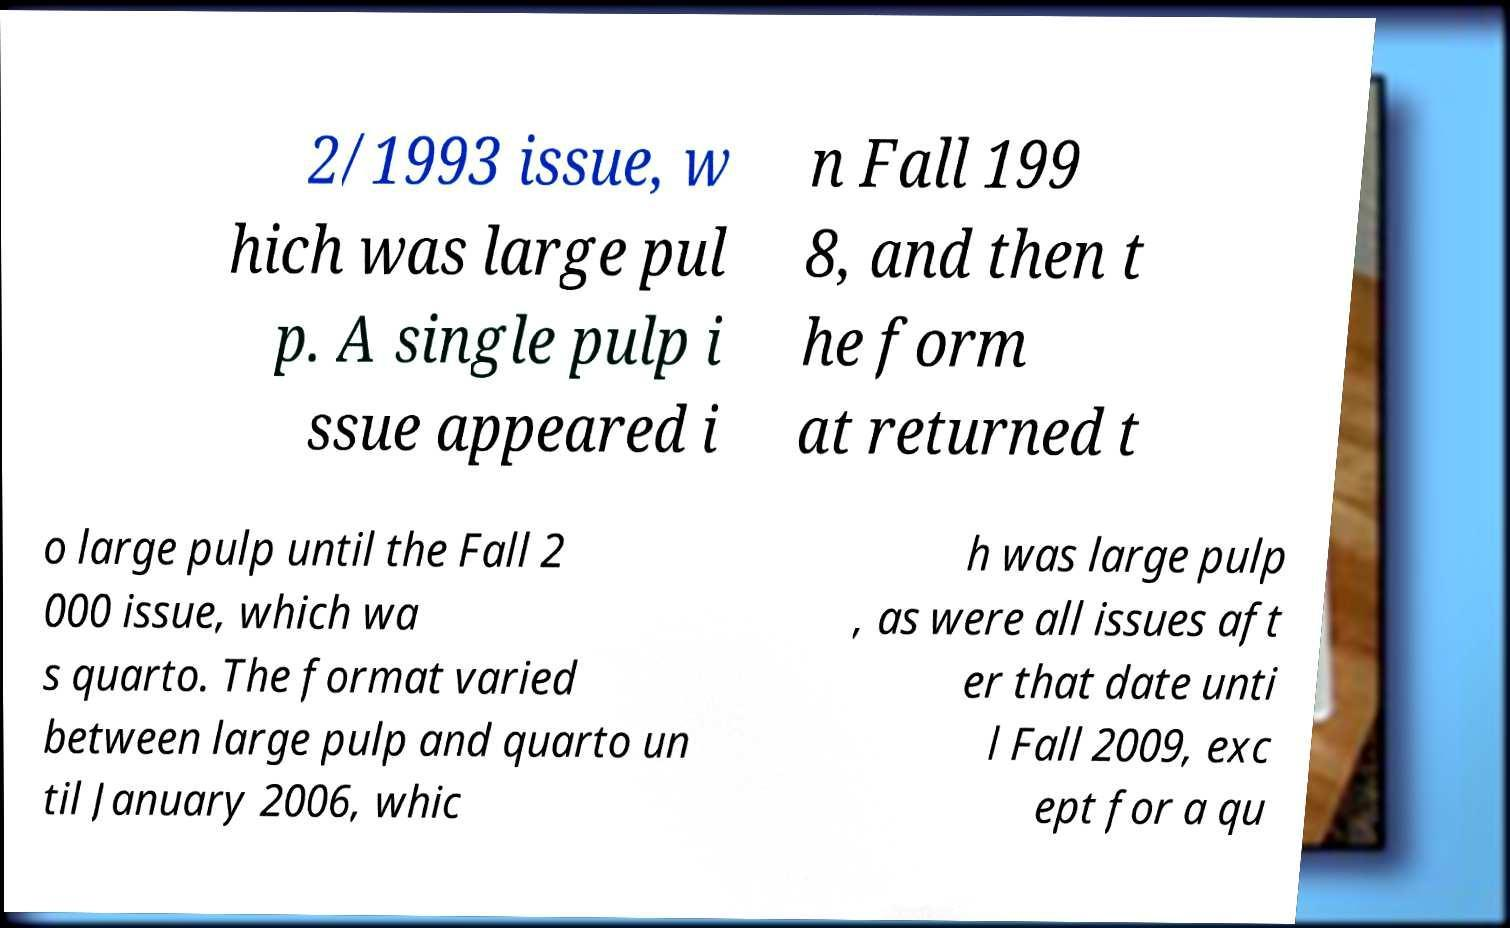Can you read and provide the text displayed in the image?This photo seems to have some interesting text. Can you extract and type it out for me? 2/1993 issue, w hich was large pul p. A single pulp i ssue appeared i n Fall 199 8, and then t he form at returned t o large pulp until the Fall 2 000 issue, which wa s quarto. The format varied between large pulp and quarto un til January 2006, whic h was large pulp , as were all issues aft er that date unti l Fall 2009, exc ept for a qu 